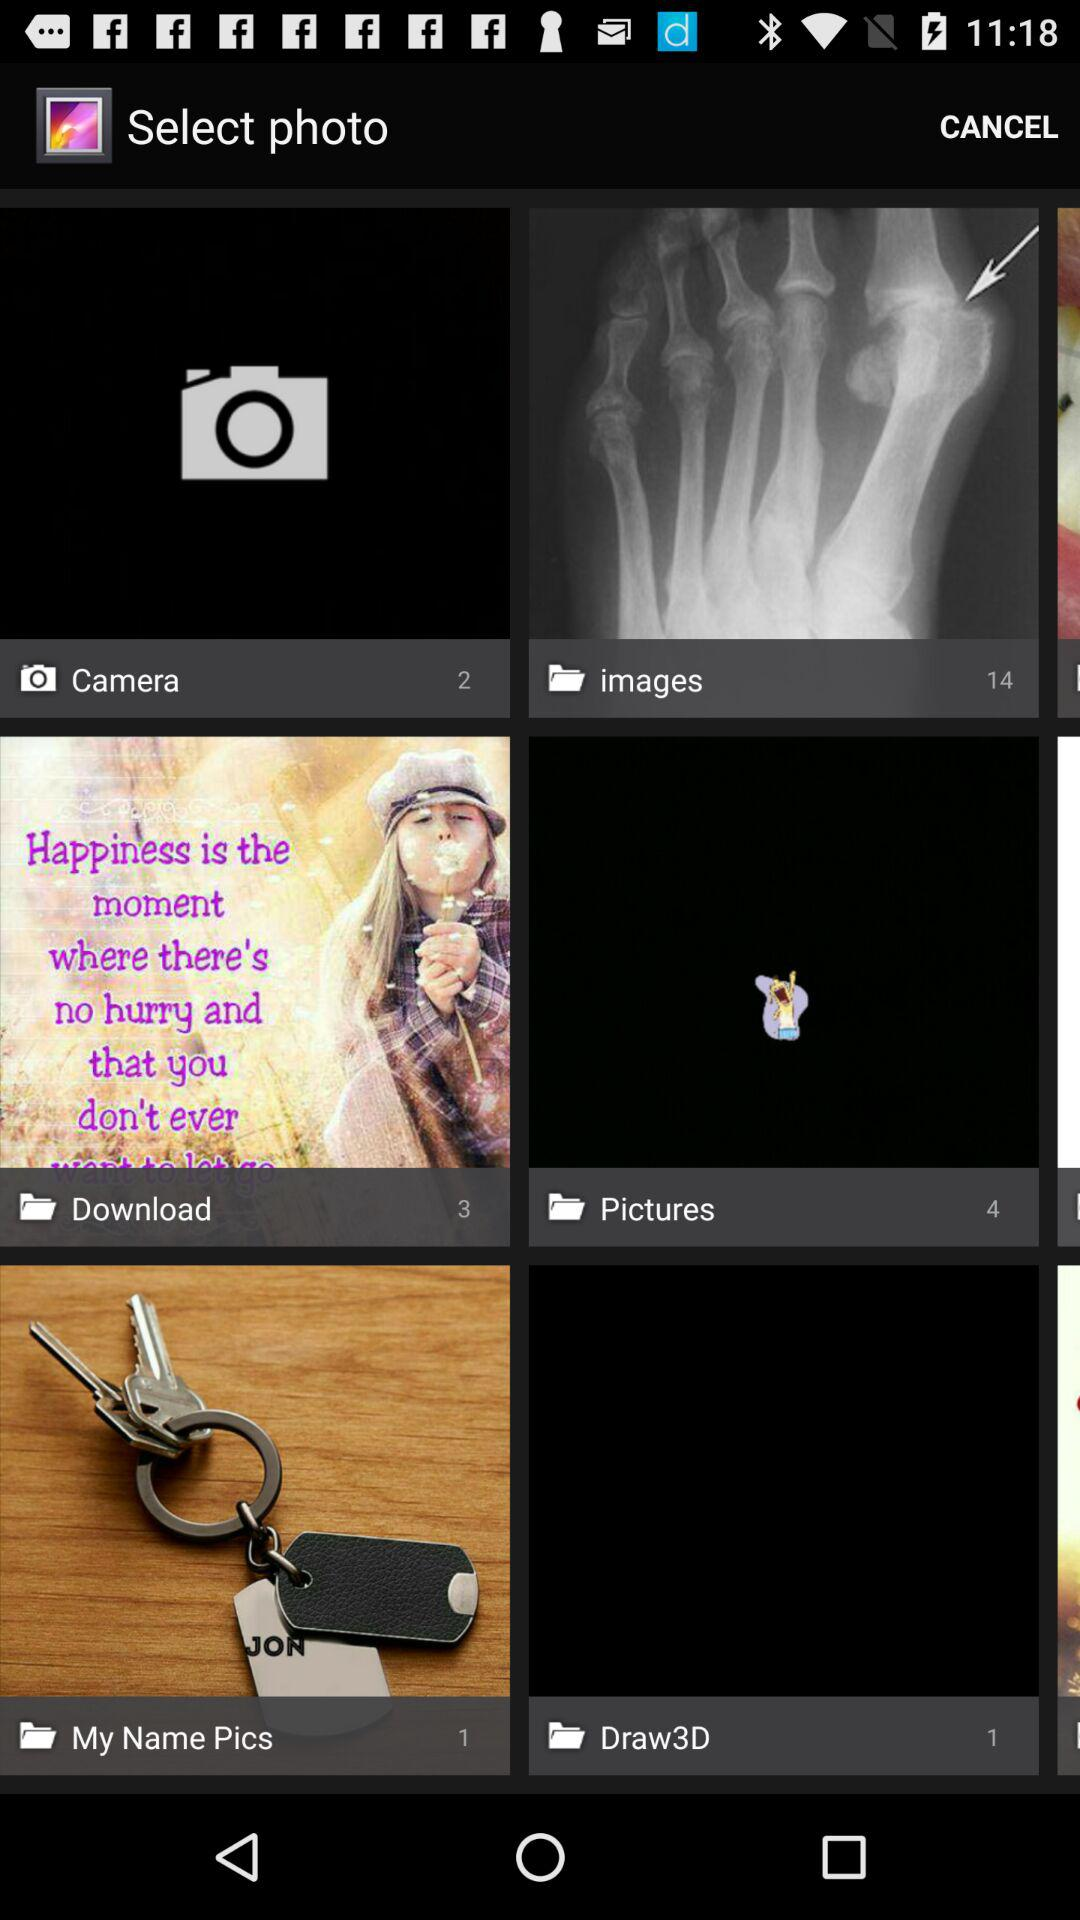What is the number of pictures in the "Pictures" folder? The number of pictures in the "Pictures" folder is 4. 